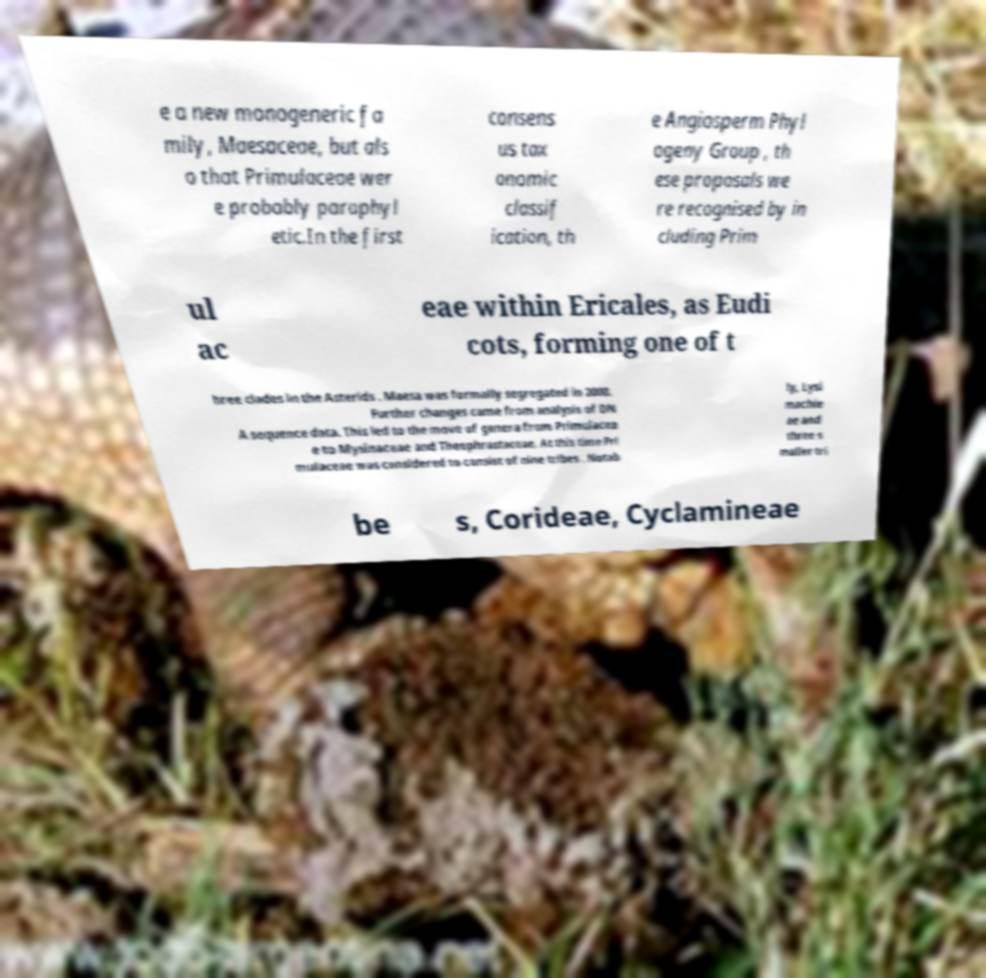I need the written content from this picture converted into text. Can you do that? e a new monogeneric fa mily, Maesaceae, but als o that Primulaceae wer e probably paraphyl etic.In the first consens us tax onomic classif ication, th e Angiosperm Phyl ogeny Group , th ese proposals we re recognised by in cluding Prim ul ac eae within Ericales, as Eudi cots, forming one of t hree clades in the Asterids . Maesa was formally segregated in 2000. Further changes came from analysis of DN A sequence data. This led to the move of genera from Primulacea e to Mysinaceae and Theophrastaceae. At this time Pri mulaceae was considered to consist of nine tribes . Notab ly, Lysi machie ae and three s maller tri be s, Corideae, Cyclamineae 